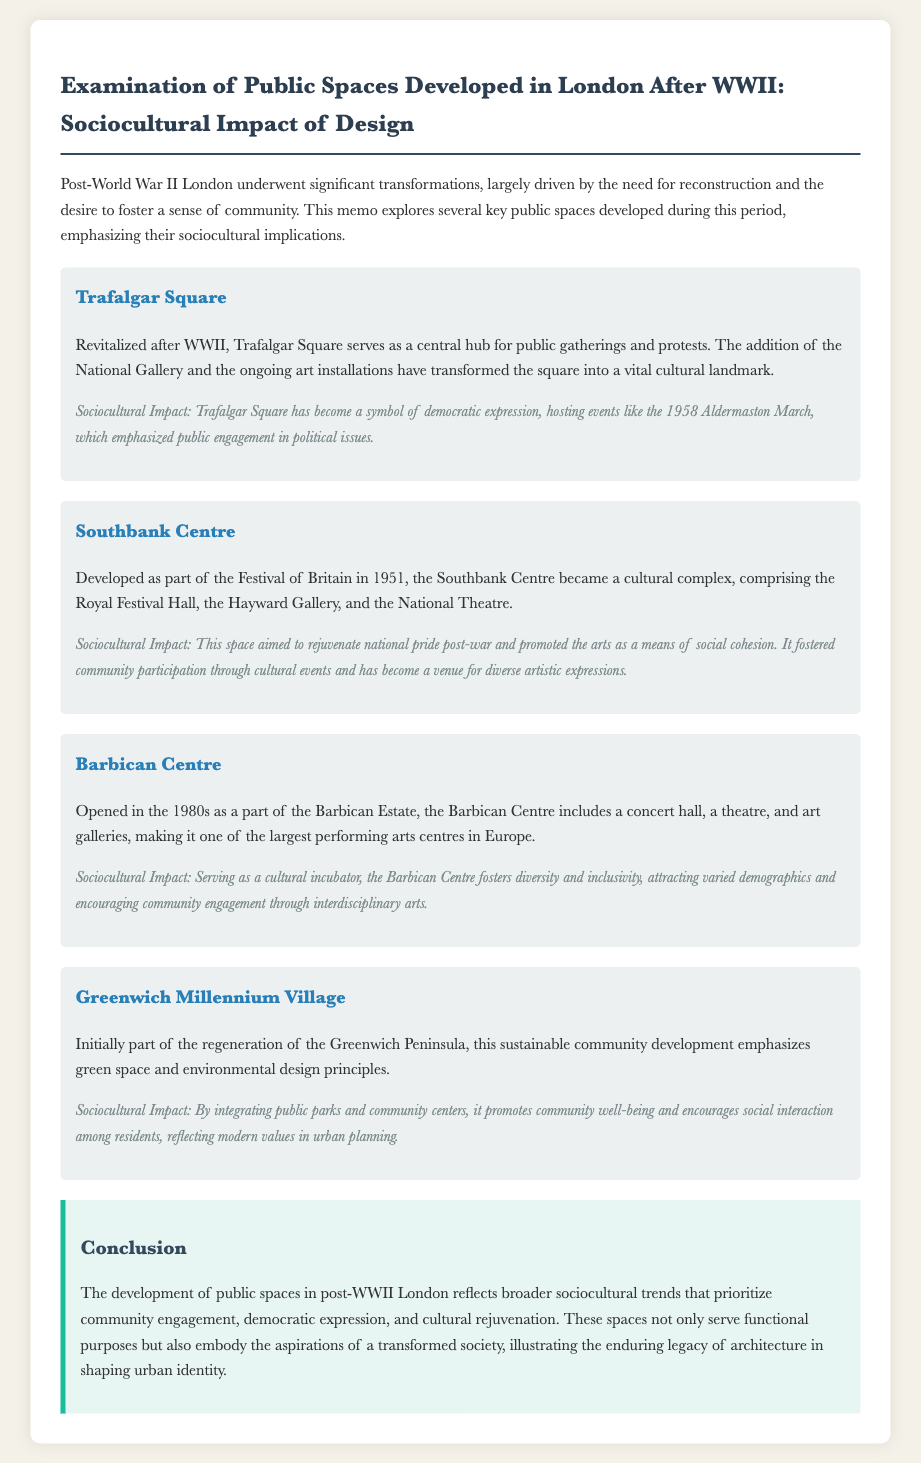What is the primary focus of the memo? The memo examines the public spaces developed in London after WWII, highlighting their sociocultural impact on the community.
Answer: Public spaces and sociocultural impact What year did the Southbank Centre open? The Southbank Centre was developed as part of the Festival of Britain in 1951.
Answer: 1951 Which public space became a symbol of democratic expression? Trafalgar Square is noted for hosting events that emphasize public engagement in political issues.
Answer: Trafalgar Square How many major components are included in the Barbican Centre? The Barbican Centre includes a concert hall, a theatre, and art galleries.
Answer: Three What is the sociocultural impact of the Greenwich Millennium Village? It promotes community well-being and encourages social interaction among residents.
Answer: Community well-being and social interaction What major event was hosted in Trafalgar Square in 1958? The 1958 Aldermaston March is an example of a significant event hosted in Trafalgar Square.
Answer: 1958 Aldermaston March What was the objective of the Southbank Centre? The Southbank Centre aimed to rejuvenate national pride post-war and promote the arts.
Answer: Rejuvenate national pride What type of development is the Greenwich Millennium Village? The Greenwich Millennium Village is emphasized as a sustainable community development.
Answer: Sustainable community development Which public space is noted for its role as a cultural incubator? The Barbican Centre is recognized for fostering diversity and inclusivity.
Answer: Barbican Centre 